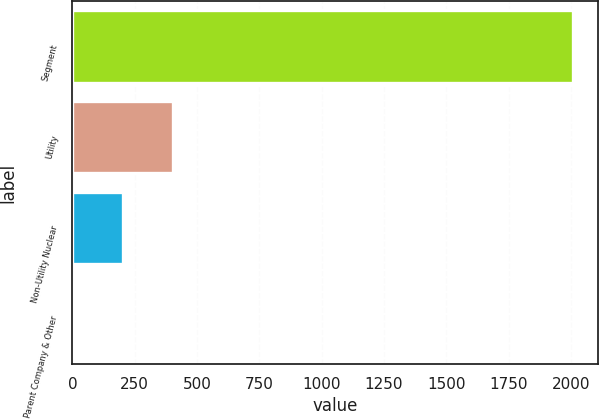Convert chart. <chart><loc_0><loc_0><loc_500><loc_500><bar_chart><fcel>Segment<fcel>Utility<fcel>Non-Utility Nuclear<fcel>Parent Company & Other<nl><fcel>2008<fcel>403.2<fcel>202.6<fcel>2<nl></chart> 